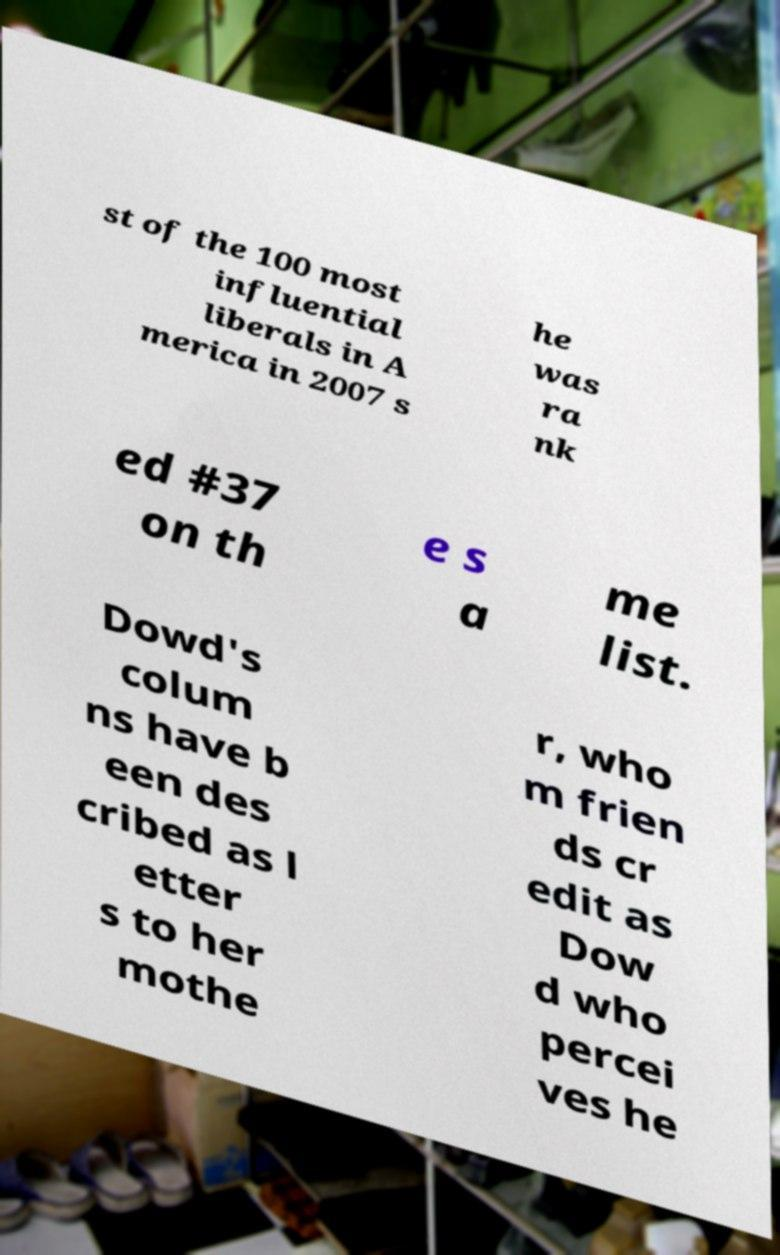Could you extract and type out the text from this image? st of the 100 most influential liberals in A merica in 2007 s he was ra nk ed #37 on th e s a me list. Dowd's colum ns have b een des cribed as l etter s to her mothe r, who m frien ds cr edit as Dow d who percei ves he 